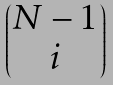Convert formula to latex. <formula><loc_0><loc_0><loc_500><loc_500>\begin{pmatrix} N - 1 \\ i \end{pmatrix}</formula> 